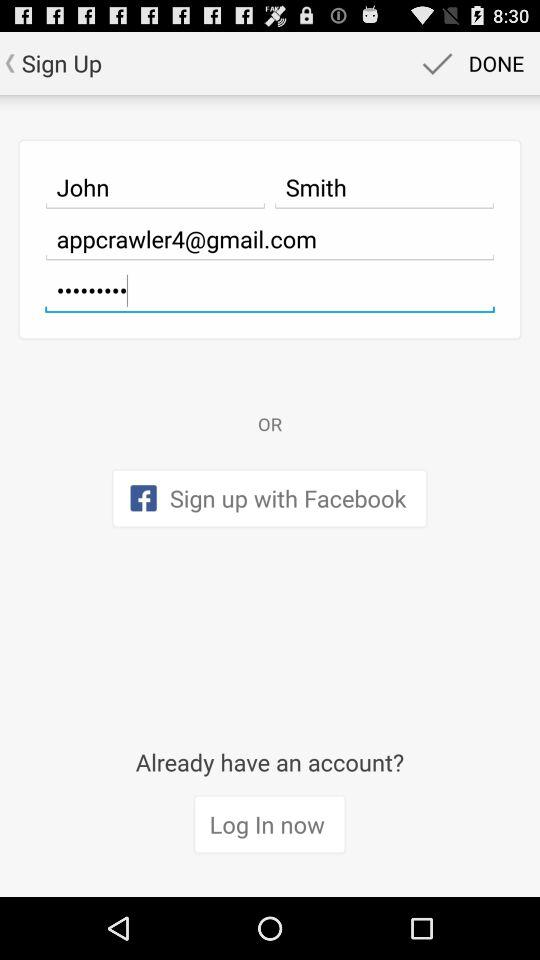What is the email address? The email address is appcrawler4@gmail.com. 